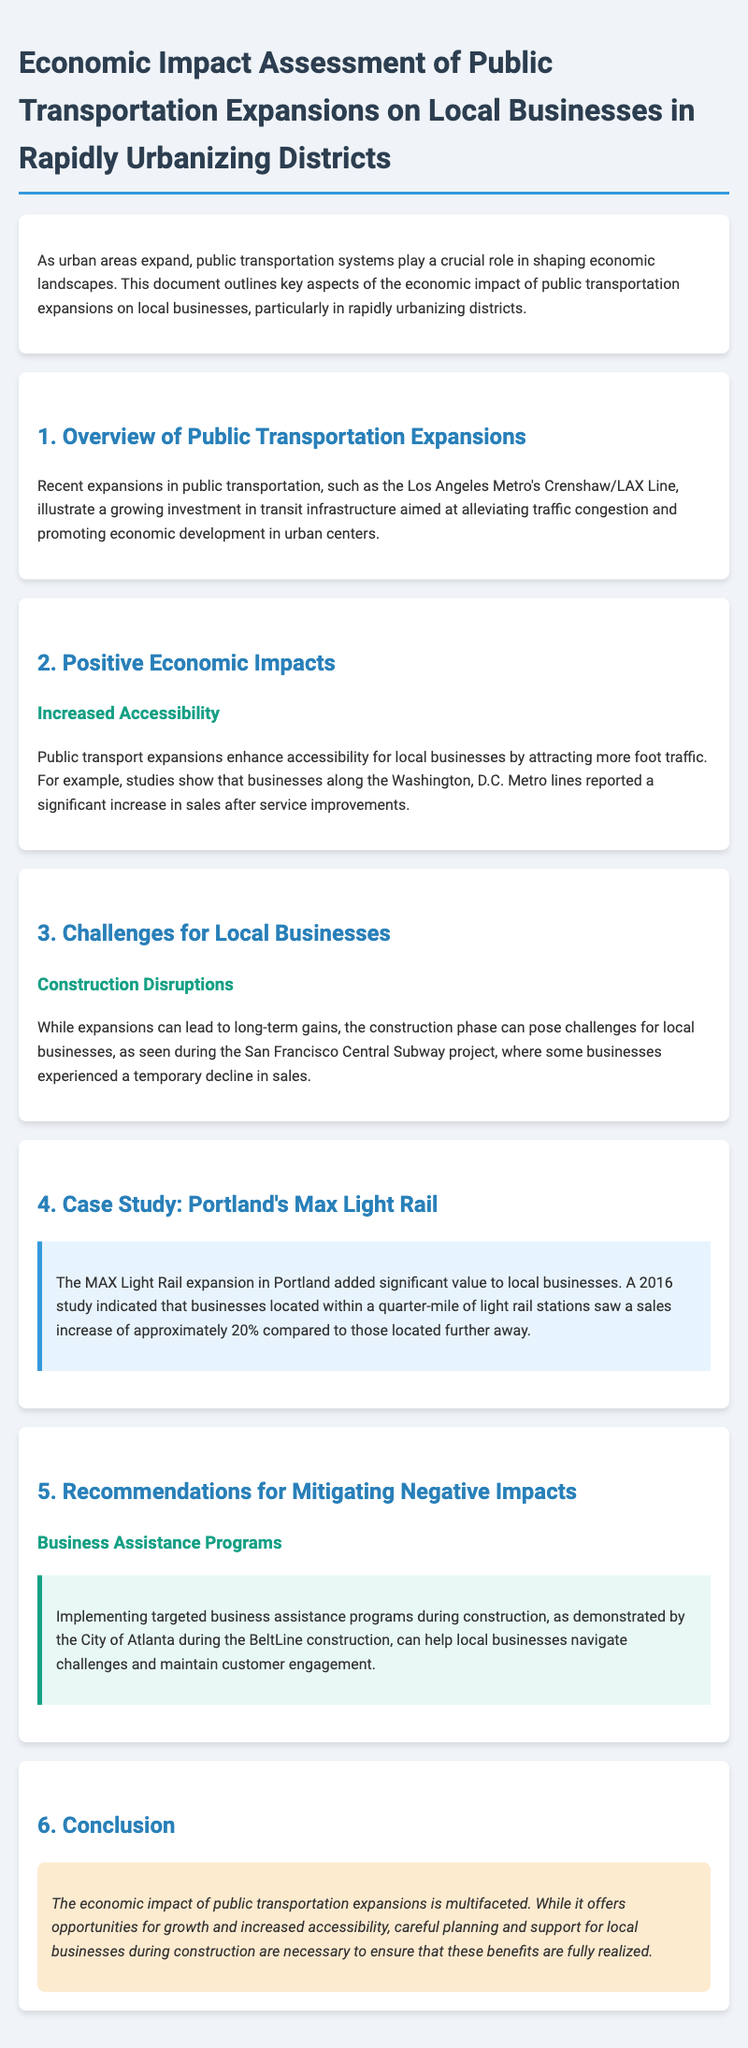What is the title of the document? The title is clearly stated at the beginning of the document, highlighting the subject matter.
Answer: Economic Impact Assessment of Public Transportation Expansions on Local Businesses in Rapidly Urbanizing Districts What case study is mentioned in the document? The document provides a specific example of a city and its transportation project that illustrates the impact on local businesses.
Answer: Portland's Max Light Rail What percentage increase in sales did businesses near MAX Light Rail stations see? The document reports on the performance of businesses near light rail stations according to a study.
Answer: 20% What city is referenced in terms of business assistance programs during construction? The document includes an example of a city implementing support programs to help local businesses during transit project disruptions.
Answer: Atlanta What challenge do businesses face during public transportation expansion? The document identifies specific issues that local businesses encounter as construction occurs.
Answer: Construction Disruptions What effect did the Crenshaw/LAX Line aim to achieve? The document outlines objectives related to the expansion of the public transit system.
Answer: Alleviating traffic congestion and promoting economic development 